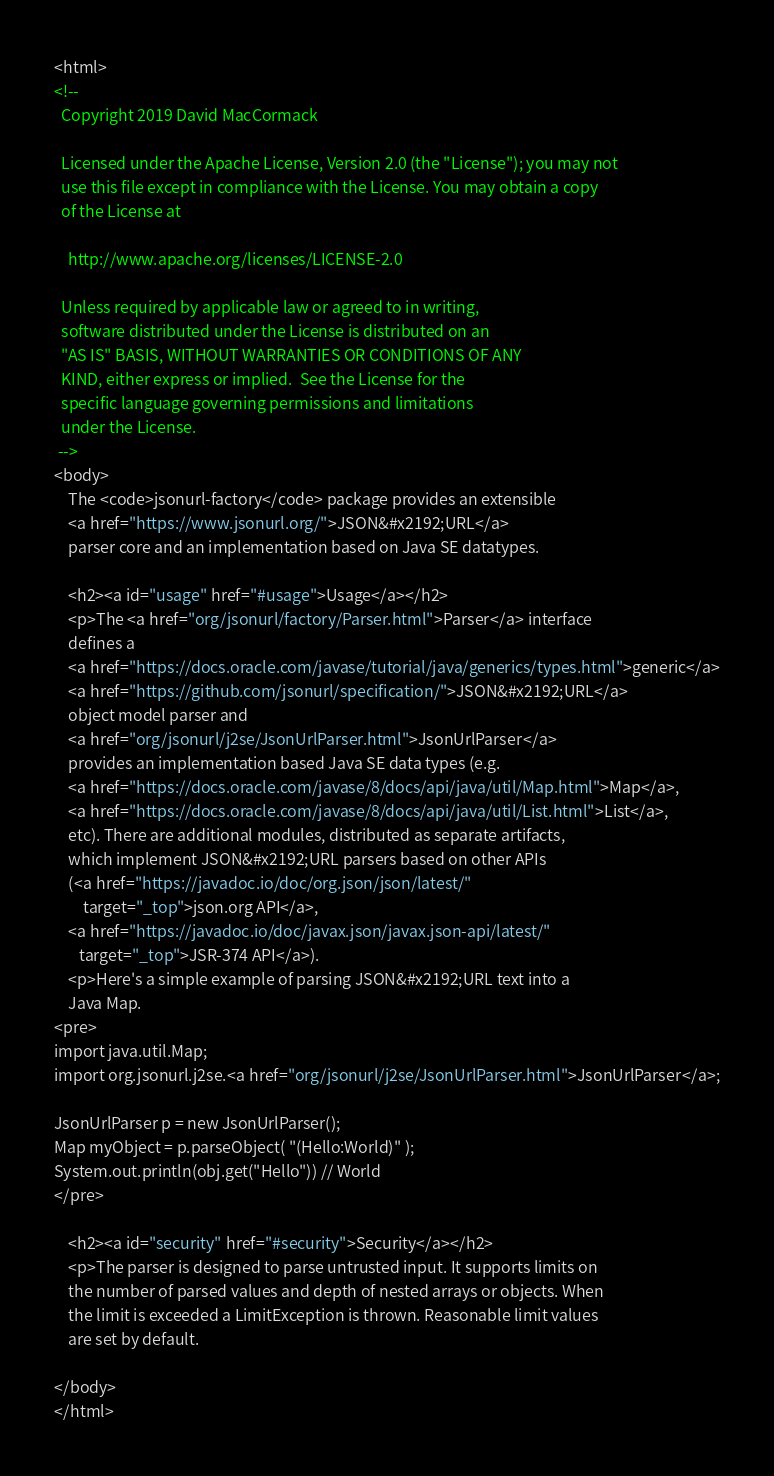<code> <loc_0><loc_0><loc_500><loc_500><_HTML_><html>
<!--
  Copyright 2019 David MacCormack

  Licensed under the Apache License, Version 2.0 (the "License"); you may not
  use this file except in compliance with the License. You may obtain a copy
  of the License at

    http://www.apache.org/licenses/LICENSE-2.0

  Unless required by applicable law or agreed to in writing,
  software distributed under the License is distributed on an
  "AS IS" BASIS, WITHOUT WARRANTIES OR CONDITIONS OF ANY
  KIND, either express or implied.  See the License for the
  specific language governing permissions and limitations
  under the License.
 -->
<body>
    The <code>jsonurl-factory</code> package provides an extensible
    <a href="https://www.jsonurl.org/">JSON&#x2192;URL</a>
    parser core and an implementation based on Java SE datatypes.

    <h2><a id="usage" href="#usage">Usage</a></h2>
    <p>The <a href="org/jsonurl/factory/Parser.html">Parser</a> interface
    defines a
    <a href="https://docs.oracle.com/javase/tutorial/java/generics/types.html">generic</a>
    <a href="https://github.com/jsonurl/specification/">JSON&#x2192;URL</a>
    object model parser and
    <a href="org/jsonurl/j2se/JsonUrlParser.html">JsonUrlParser</a>
    provides an implementation based Java SE data types (e.g.
    <a href="https://docs.oracle.com/javase/8/docs/api/java/util/Map.html">Map</a>,
    <a href="https://docs.oracle.com/javase/8/docs/api/java/util/List.html">List</a>,
    etc). There are additional modules, distributed as separate artifacts,
    which implement JSON&#x2192;URL parsers based on other APIs
    (<a href="https://javadoc.io/doc/org.json/json/latest/"
        target="_top">json.org API</a>,
    <a href="https://javadoc.io/doc/javax.json/javax.json-api/latest/"
       target="_top">JSR-374 API</a>).
    <p>Here's a simple example of parsing JSON&#x2192;URL text into a
    Java Map. 
<pre>
import java.util.Map;
import org.jsonurl.j2se.<a href="org/jsonurl/j2se/JsonUrlParser.html">JsonUrlParser</a>;

JsonUrlParser p = new JsonUrlParser();
Map myObject = p.parseObject( "(Hello:World)" );
System.out.println(obj.get("Hello")) // World
</pre>
  
    <h2><a id="security" href="#security">Security</a></h2>
    <p>The parser is designed to parse untrusted input. It supports limits on
    the number of parsed values and depth of nested arrays or objects. When
    the limit is exceeded a LimitException is thrown. Reasonable limit values
    are set by default.

</body>
</html></code> 